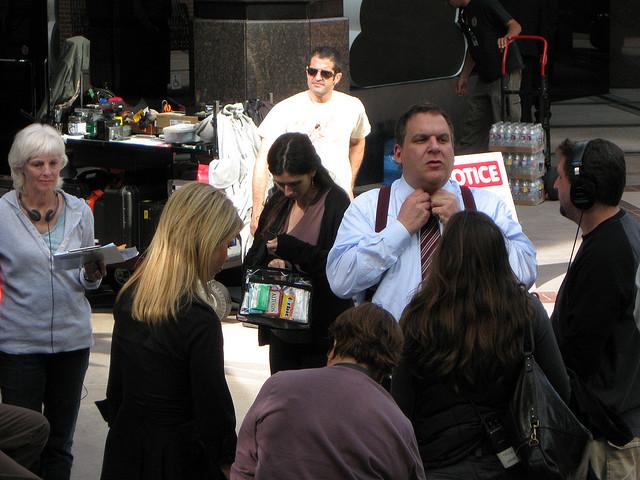What is over the man's ears?
Be succinct. Headphones. Does the tie match the suspenders?
Give a very brief answer. Yes. Where are the bottled waters?
Concise answer only. Back area on right. 